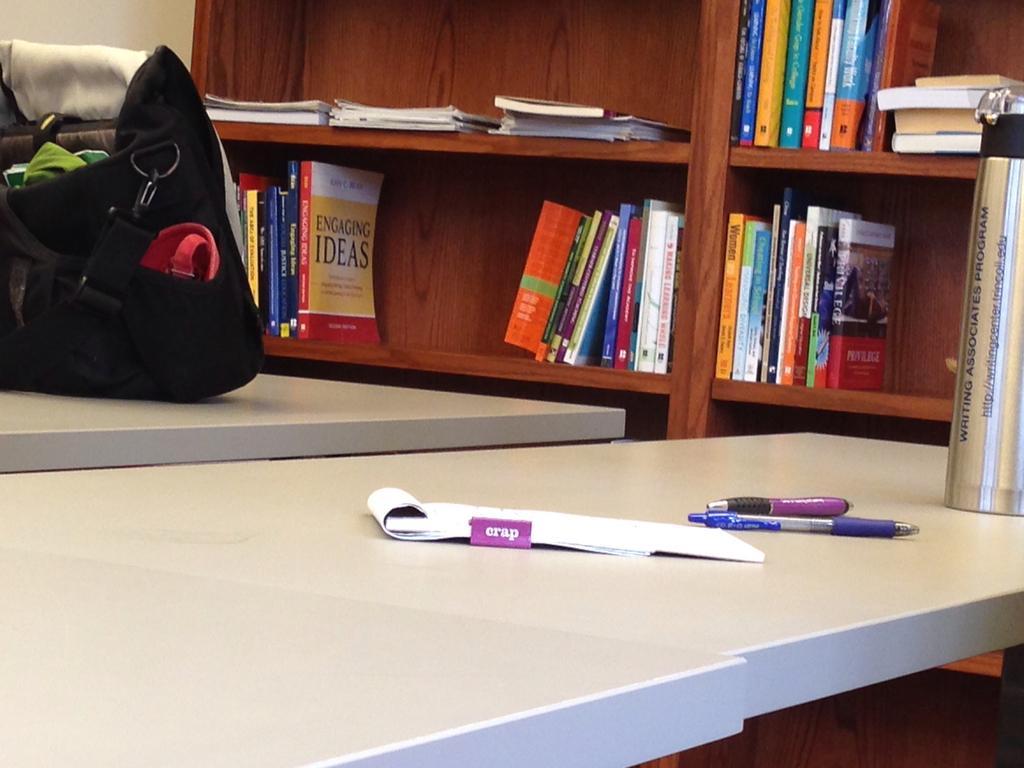In one or two sentences, can you explain what this image depicts? In this image, there is an inside view of a room. There is a bookshelf at the top of this image contains some books. At the bottom, there are two tables contains bag, book, pens and flask. 